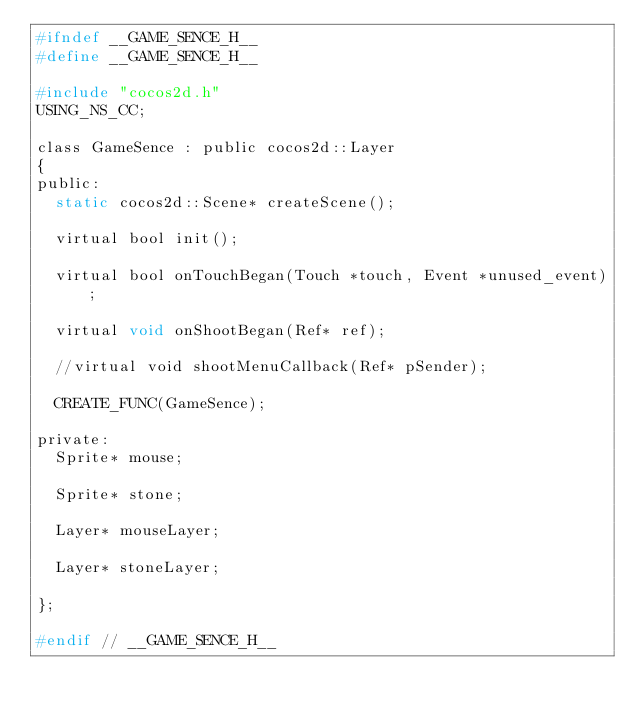<code> <loc_0><loc_0><loc_500><loc_500><_C_>#ifndef __GAME_SENCE_H__
#define __GAME_SENCE_H__

#include "cocos2d.h"
USING_NS_CC;

class GameSence : public cocos2d::Layer
{
public:
	static cocos2d::Scene* createScene();

	virtual bool init();

	virtual bool onTouchBegan(Touch *touch, Event *unused_event);

	virtual void onShootBegan(Ref* ref);

	//virtual void shootMenuCallback(Ref* pSender);

	CREATE_FUNC(GameSence);

private:
	Sprite* mouse;

	Sprite* stone;
	
	Layer* mouseLayer;
	
	Layer* stoneLayer;

};

#endif // __GAME_SENCE_H__

</code> 